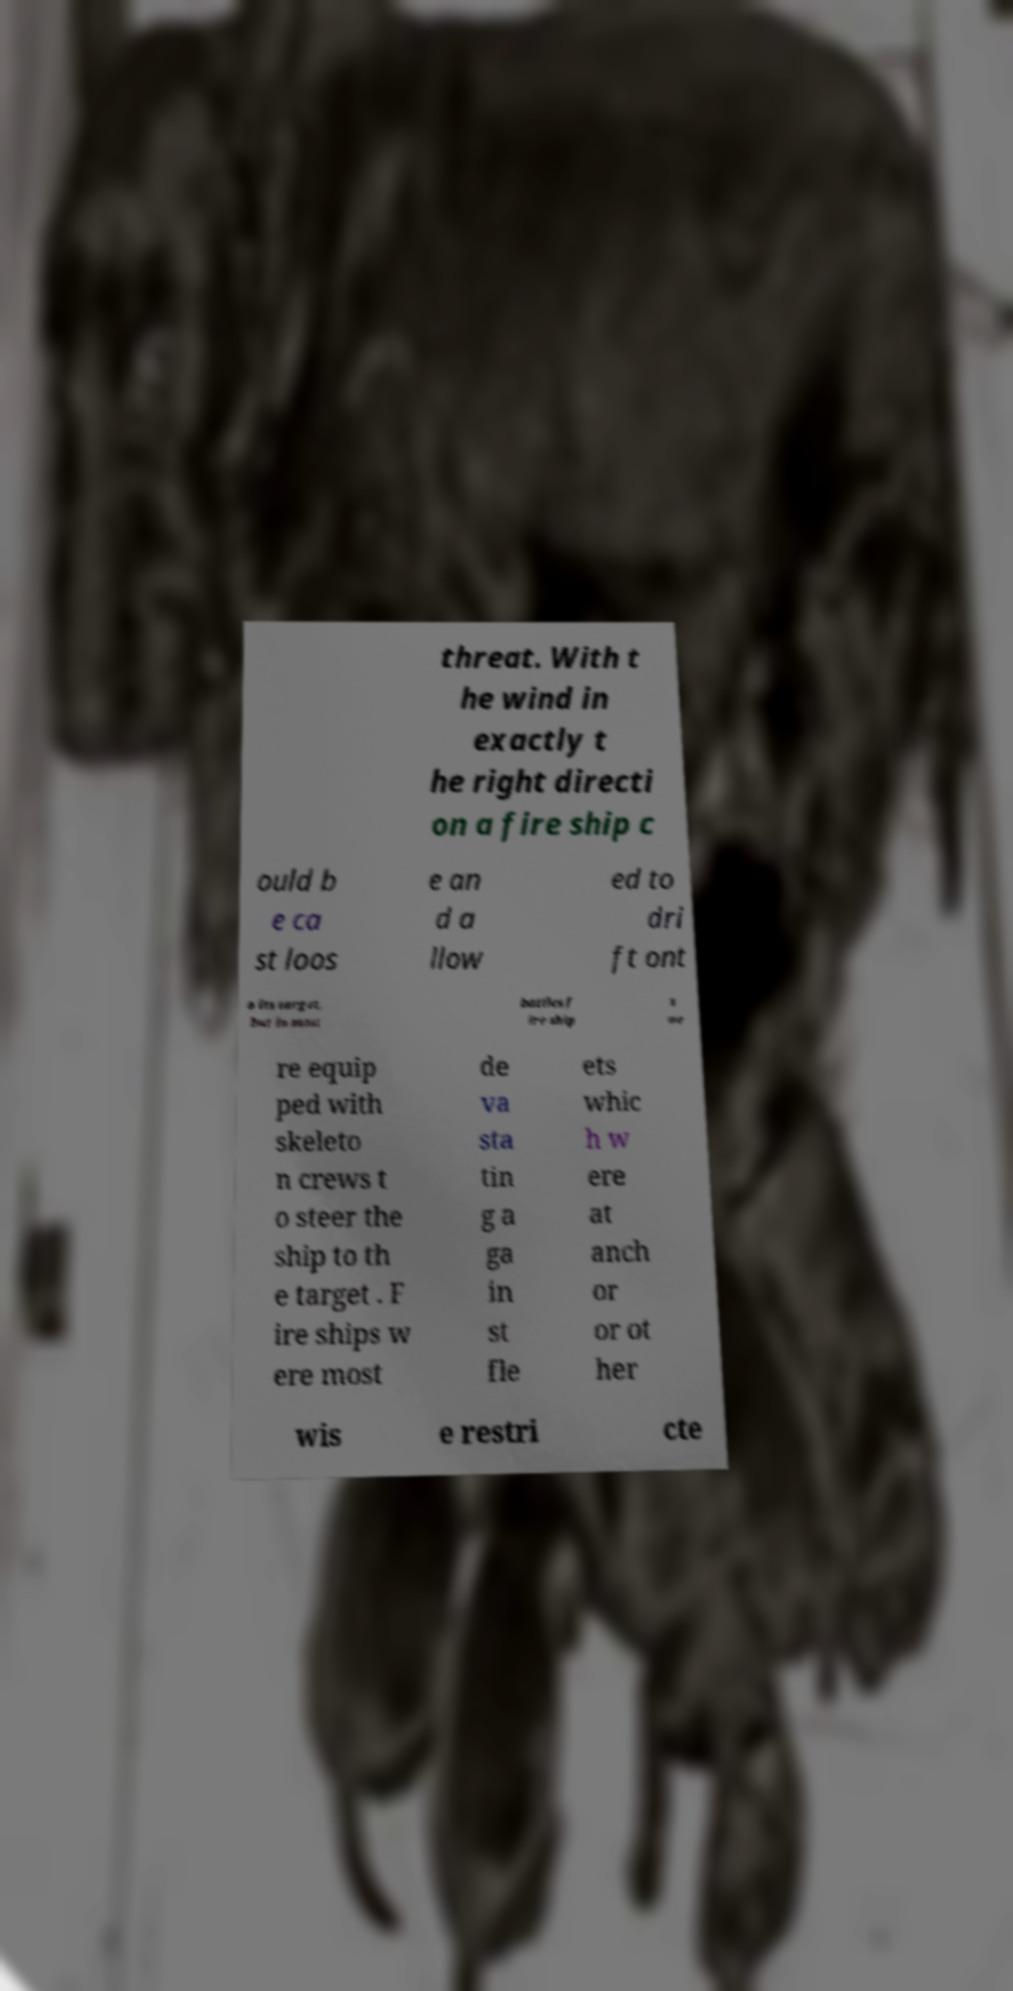Could you assist in decoding the text presented in this image and type it out clearly? threat. With t he wind in exactly t he right directi on a fire ship c ould b e ca st loos e an d a llow ed to dri ft ont o its target, but in most battles f ire ship s we re equip ped with skeleto n crews t o steer the ship to th e target . F ire ships w ere most de va sta tin g a ga in st fle ets whic h w ere at anch or or ot her wis e restri cte 